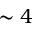Convert formula to latex. <formula><loc_0><loc_0><loc_500><loc_500>\sim 4</formula> 